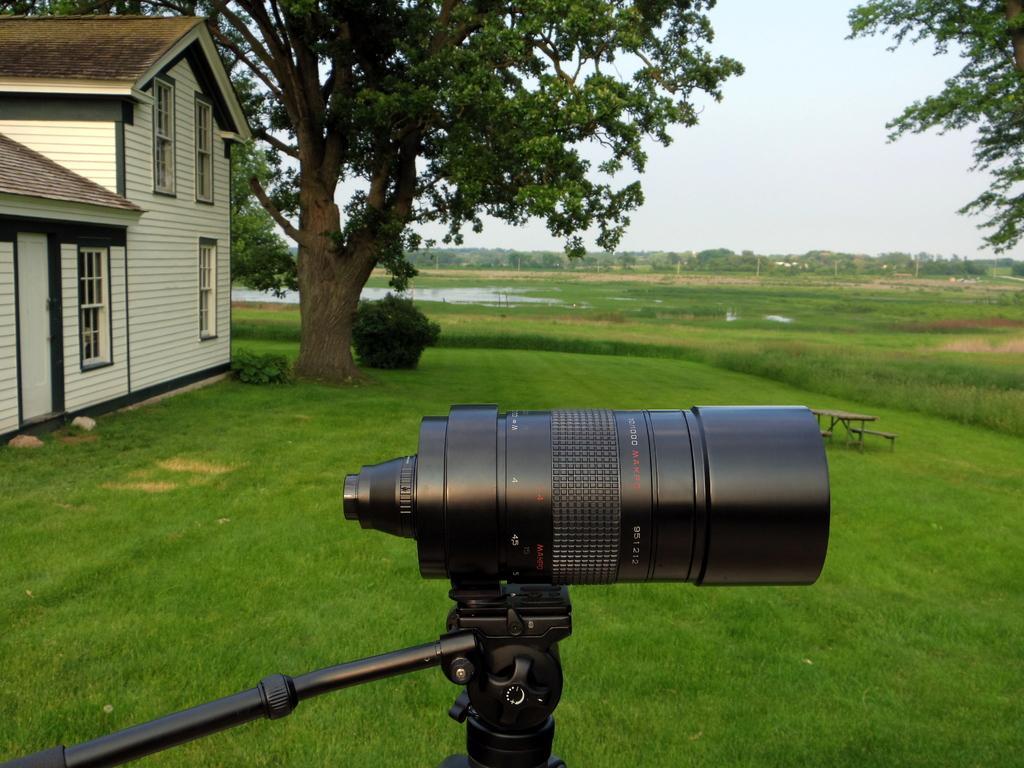How would you summarize this image in a sentence or two? This picture is clicked outside. In the foreground there is a camera attached to the stand. On the left we can see the house and a tree and some plants. In the background there is a sky and the trees and a water body and we can see the green grass and a bench and a table placed on the ground. 